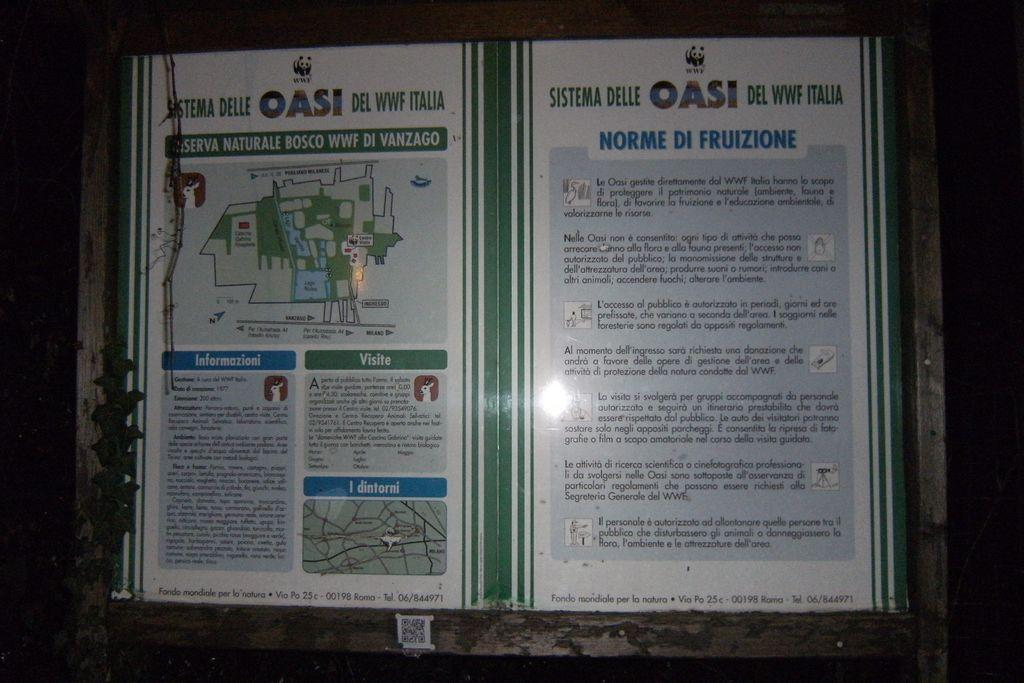Provide a one-sentence caption for the provided image. A map is posted for the Oasi del WWF Italia. 